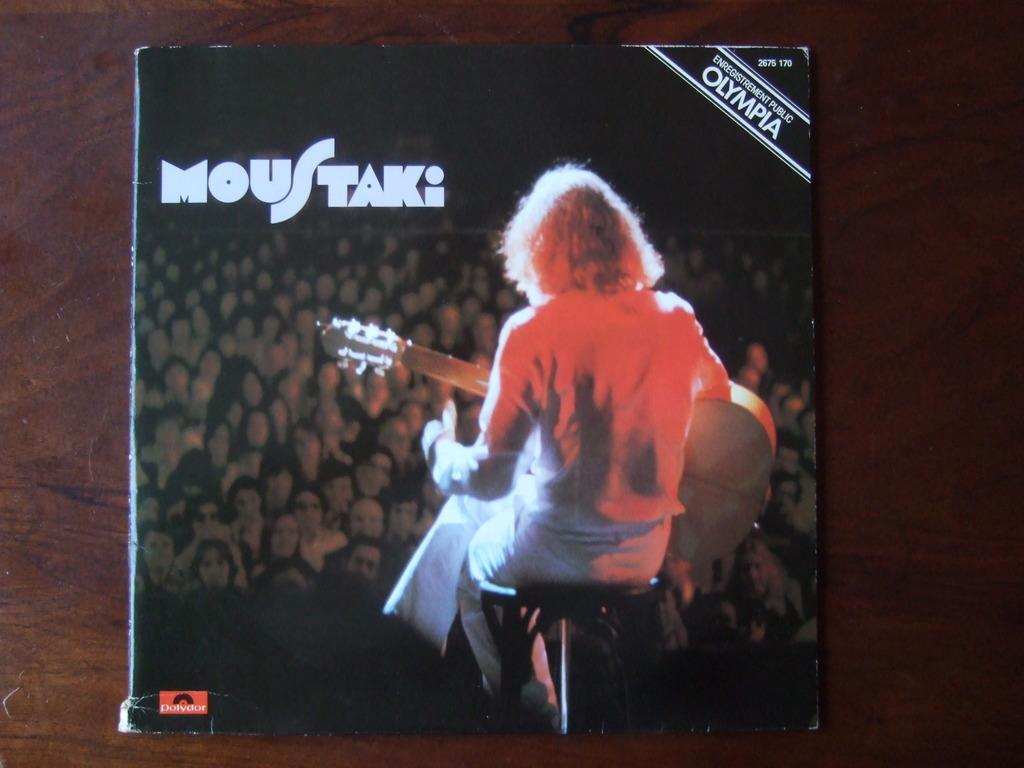What's the name at the top of the right page?
Provide a succinct answer. Olympia. 